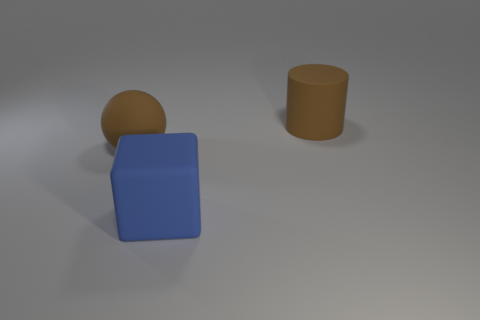Could you describe the shapes and their arrangement in the image? Certainly! The image contains three geometric shapes: a large blue cube at the forefront, which is positioned slightly off-center; a brown sphere to the left in the background; and a brown cylinder to the right. The arrangement is fairly spaced out, with no shape overlapping the other, and each can be distinctly seen against the neutral background. 